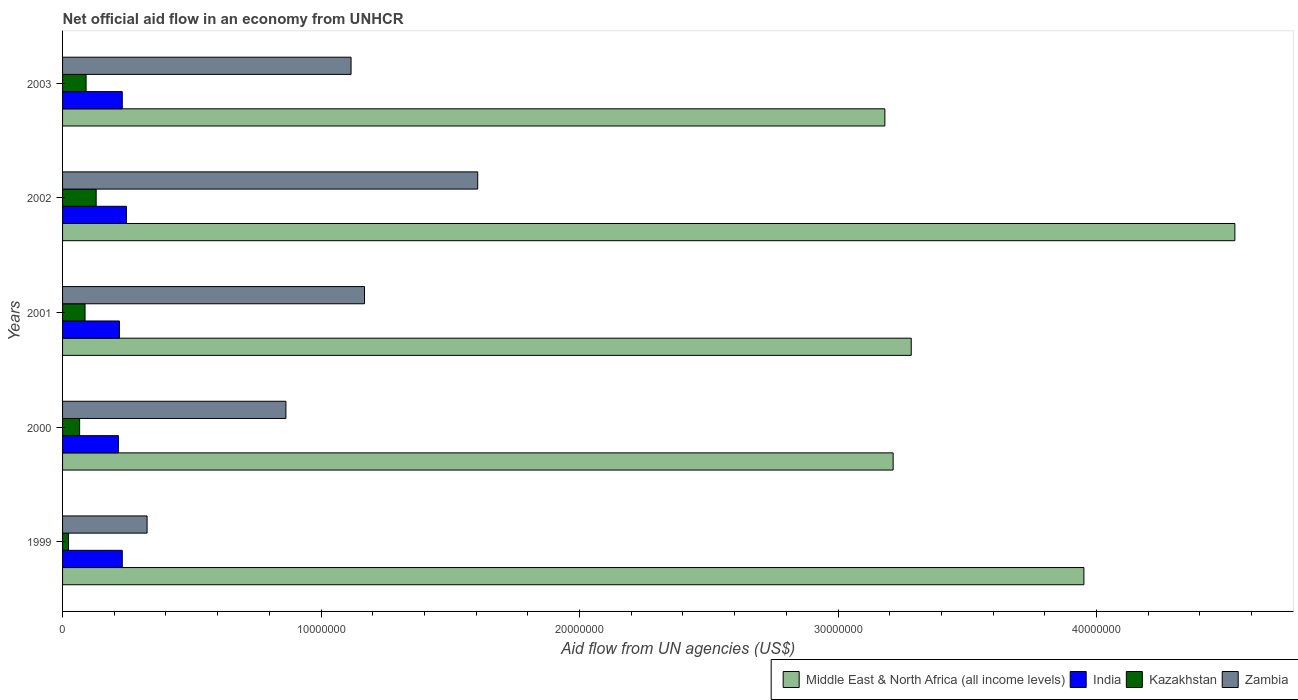How many different coloured bars are there?
Make the answer very short. 4. Are the number of bars on each tick of the Y-axis equal?
Your answer should be very brief. Yes. How many bars are there on the 2nd tick from the top?
Provide a succinct answer. 4. What is the label of the 4th group of bars from the top?
Give a very brief answer. 2000. What is the net official aid flow in Middle East & North Africa (all income levels) in 2001?
Your answer should be compact. 3.28e+07. Across all years, what is the maximum net official aid flow in Middle East & North Africa (all income levels)?
Keep it short and to the point. 4.54e+07. Across all years, what is the minimum net official aid flow in Middle East & North Africa (all income levels)?
Make the answer very short. 3.18e+07. In which year was the net official aid flow in Middle East & North Africa (all income levels) minimum?
Provide a short and direct response. 2003. What is the total net official aid flow in Middle East & North Africa (all income levels) in the graph?
Make the answer very short. 1.82e+08. What is the difference between the net official aid flow in Middle East & North Africa (all income levels) in 2000 and that in 2001?
Your response must be concise. -7.00e+05. What is the difference between the net official aid flow in Kazakhstan in 1999 and the net official aid flow in Middle East & North Africa (all income levels) in 2003?
Your response must be concise. -3.16e+07. What is the average net official aid flow in Zambia per year?
Keep it short and to the point. 1.02e+07. In the year 2001, what is the difference between the net official aid flow in India and net official aid flow in Middle East & North Africa (all income levels)?
Ensure brevity in your answer.  -3.06e+07. In how many years, is the net official aid flow in Middle East & North Africa (all income levels) greater than 20000000 US$?
Provide a short and direct response. 5. What is the ratio of the net official aid flow in Kazakhstan in 2000 to that in 2002?
Give a very brief answer. 0.51. Is the net official aid flow in Kazakhstan in 2001 less than that in 2003?
Offer a very short reply. Yes. Is the difference between the net official aid flow in India in 2001 and 2002 greater than the difference between the net official aid flow in Middle East & North Africa (all income levels) in 2001 and 2002?
Ensure brevity in your answer.  Yes. What is the difference between the highest and the lowest net official aid flow in India?
Your answer should be very brief. 3.10e+05. In how many years, is the net official aid flow in Zambia greater than the average net official aid flow in Zambia taken over all years?
Make the answer very short. 3. Is the sum of the net official aid flow in Zambia in 1999 and 2002 greater than the maximum net official aid flow in Middle East & North Africa (all income levels) across all years?
Offer a very short reply. No. What does the 3rd bar from the bottom in 2000 represents?
Keep it short and to the point. Kazakhstan. Is it the case that in every year, the sum of the net official aid flow in Middle East & North Africa (all income levels) and net official aid flow in Kazakhstan is greater than the net official aid flow in Zambia?
Keep it short and to the point. Yes. Does the graph contain grids?
Your answer should be compact. No. How many legend labels are there?
Ensure brevity in your answer.  4. How are the legend labels stacked?
Offer a very short reply. Horizontal. What is the title of the graph?
Your response must be concise. Net official aid flow in an economy from UNHCR. Does "Mozambique" appear as one of the legend labels in the graph?
Provide a short and direct response. No. What is the label or title of the X-axis?
Provide a short and direct response. Aid flow from UN agencies (US$). What is the Aid flow from UN agencies (US$) in Middle East & North Africa (all income levels) in 1999?
Offer a very short reply. 3.95e+07. What is the Aid flow from UN agencies (US$) of India in 1999?
Give a very brief answer. 2.31e+06. What is the Aid flow from UN agencies (US$) in Kazakhstan in 1999?
Offer a very short reply. 2.30e+05. What is the Aid flow from UN agencies (US$) in Zambia in 1999?
Ensure brevity in your answer.  3.27e+06. What is the Aid flow from UN agencies (US$) of Middle East & North Africa (all income levels) in 2000?
Offer a terse response. 3.21e+07. What is the Aid flow from UN agencies (US$) in India in 2000?
Make the answer very short. 2.16e+06. What is the Aid flow from UN agencies (US$) of Zambia in 2000?
Make the answer very short. 8.64e+06. What is the Aid flow from UN agencies (US$) of Middle East & North Africa (all income levels) in 2001?
Ensure brevity in your answer.  3.28e+07. What is the Aid flow from UN agencies (US$) of India in 2001?
Offer a terse response. 2.20e+06. What is the Aid flow from UN agencies (US$) of Kazakhstan in 2001?
Offer a terse response. 8.70e+05. What is the Aid flow from UN agencies (US$) in Zambia in 2001?
Give a very brief answer. 1.17e+07. What is the Aid flow from UN agencies (US$) in Middle East & North Africa (all income levels) in 2002?
Offer a very short reply. 4.54e+07. What is the Aid flow from UN agencies (US$) in India in 2002?
Provide a succinct answer. 2.47e+06. What is the Aid flow from UN agencies (US$) in Kazakhstan in 2002?
Provide a short and direct response. 1.30e+06. What is the Aid flow from UN agencies (US$) in Zambia in 2002?
Your answer should be very brief. 1.61e+07. What is the Aid flow from UN agencies (US$) in Middle East & North Africa (all income levels) in 2003?
Your response must be concise. 3.18e+07. What is the Aid flow from UN agencies (US$) of India in 2003?
Your answer should be very brief. 2.31e+06. What is the Aid flow from UN agencies (US$) of Kazakhstan in 2003?
Provide a succinct answer. 9.10e+05. What is the Aid flow from UN agencies (US$) in Zambia in 2003?
Offer a terse response. 1.12e+07. Across all years, what is the maximum Aid flow from UN agencies (US$) of Middle East & North Africa (all income levels)?
Your answer should be very brief. 4.54e+07. Across all years, what is the maximum Aid flow from UN agencies (US$) of India?
Ensure brevity in your answer.  2.47e+06. Across all years, what is the maximum Aid flow from UN agencies (US$) in Kazakhstan?
Your response must be concise. 1.30e+06. Across all years, what is the maximum Aid flow from UN agencies (US$) in Zambia?
Your answer should be very brief. 1.61e+07. Across all years, what is the minimum Aid flow from UN agencies (US$) in Middle East & North Africa (all income levels)?
Ensure brevity in your answer.  3.18e+07. Across all years, what is the minimum Aid flow from UN agencies (US$) in India?
Your response must be concise. 2.16e+06. Across all years, what is the minimum Aid flow from UN agencies (US$) of Zambia?
Your answer should be compact. 3.27e+06. What is the total Aid flow from UN agencies (US$) of Middle East & North Africa (all income levels) in the graph?
Your answer should be compact. 1.82e+08. What is the total Aid flow from UN agencies (US$) of India in the graph?
Offer a terse response. 1.14e+07. What is the total Aid flow from UN agencies (US$) in Kazakhstan in the graph?
Provide a short and direct response. 3.97e+06. What is the total Aid flow from UN agencies (US$) in Zambia in the graph?
Provide a succinct answer. 5.08e+07. What is the difference between the Aid flow from UN agencies (US$) of Middle East & North Africa (all income levels) in 1999 and that in 2000?
Keep it short and to the point. 7.38e+06. What is the difference between the Aid flow from UN agencies (US$) in India in 1999 and that in 2000?
Your response must be concise. 1.50e+05. What is the difference between the Aid flow from UN agencies (US$) of Kazakhstan in 1999 and that in 2000?
Provide a succinct answer. -4.30e+05. What is the difference between the Aid flow from UN agencies (US$) in Zambia in 1999 and that in 2000?
Provide a short and direct response. -5.37e+06. What is the difference between the Aid flow from UN agencies (US$) in Middle East & North Africa (all income levels) in 1999 and that in 2001?
Offer a very short reply. 6.68e+06. What is the difference between the Aid flow from UN agencies (US$) in India in 1999 and that in 2001?
Ensure brevity in your answer.  1.10e+05. What is the difference between the Aid flow from UN agencies (US$) of Kazakhstan in 1999 and that in 2001?
Give a very brief answer. -6.40e+05. What is the difference between the Aid flow from UN agencies (US$) in Zambia in 1999 and that in 2001?
Provide a succinct answer. -8.41e+06. What is the difference between the Aid flow from UN agencies (US$) in Middle East & North Africa (all income levels) in 1999 and that in 2002?
Make the answer very short. -5.84e+06. What is the difference between the Aid flow from UN agencies (US$) in India in 1999 and that in 2002?
Ensure brevity in your answer.  -1.60e+05. What is the difference between the Aid flow from UN agencies (US$) in Kazakhstan in 1999 and that in 2002?
Your response must be concise. -1.07e+06. What is the difference between the Aid flow from UN agencies (US$) of Zambia in 1999 and that in 2002?
Keep it short and to the point. -1.28e+07. What is the difference between the Aid flow from UN agencies (US$) in Middle East & North Africa (all income levels) in 1999 and that in 2003?
Keep it short and to the point. 7.70e+06. What is the difference between the Aid flow from UN agencies (US$) in Kazakhstan in 1999 and that in 2003?
Your response must be concise. -6.80e+05. What is the difference between the Aid flow from UN agencies (US$) of Zambia in 1999 and that in 2003?
Ensure brevity in your answer.  -7.89e+06. What is the difference between the Aid flow from UN agencies (US$) in Middle East & North Africa (all income levels) in 2000 and that in 2001?
Offer a very short reply. -7.00e+05. What is the difference between the Aid flow from UN agencies (US$) of Zambia in 2000 and that in 2001?
Keep it short and to the point. -3.04e+06. What is the difference between the Aid flow from UN agencies (US$) in Middle East & North Africa (all income levels) in 2000 and that in 2002?
Your response must be concise. -1.32e+07. What is the difference between the Aid flow from UN agencies (US$) of India in 2000 and that in 2002?
Offer a very short reply. -3.10e+05. What is the difference between the Aid flow from UN agencies (US$) of Kazakhstan in 2000 and that in 2002?
Give a very brief answer. -6.40e+05. What is the difference between the Aid flow from UN agencies (US$) in Zambia in 2000 and that in 2002?
Your answer should be compact. -7.42e+06. What is the difference between the Aid flow from UN agencies (US$) of Zambia in 2000 and that in 2003?
Ensure brevity in your answer.  -2.52e+06. What is the difference between the Aid flow from UN agencies (US$) of Middle East & North Africa (all income levels) in 2001 and that in 2002?
Offer a terse response. -1.25e+07. What is the difference between the Aid flow from UN agencies (US$) in Kazakhstan in 2001 and that in 2002?
Offer a very short reply. -4.30e+05. What is the difference between the Aid flow from UN agencies (US$) of Zambia in 2001 and that in 2002?
Provide a succinct answer. -4.38e+06. What is the difference between the Aid flow from UN agencies (US$) in Middle East & North Africa (all income levels) in 2001 and that in 2003?
Your answer should be compact. 1.02e+06. What is the difference between the Aid flow from UN agencies (US$) of Zambia in 2001 and that in 2003?
Offer a terse response. 5.20e+05. What is the difference between the Aid flow from UN agencies (US$) of Middle East & North Africa (all income levels) in 2002 and that in 2003?
Provide a succinct answer. 1.35e+07. What is the difference between the Aid flow from UN agencies (US$) in Kazakhstan in 2002 and that in 2003?
Your answer should be very brief. 3.90e+05. What is the difference between the Aid flow from UN agencies (US$) in Zambia in 2002 and that in 2003?
Your answer should be compact. 4.90e+06. What is the difference between the Aid flow from UN agencies (US$) of Middle East & North Africa (all income levels) in 1999 and the Aid flow from UN agencies (US$) of India in 2000?
Give a very brief answer. 3.74e+07. What is the difference between the Aid flow from UN agencies (US$) in Middle East & North Africa (all income levels) in 1999 and the Aid flow from UN agencies (US$) in Kazakhstan in 2000?
Ensure brevity in your answer.  3.88e+07. What is the difference between the Aid flow from UN agencies (US$) in Middle East & North Africa (all income levels) in 1999 and the Aid flow from UN agencies (US$) in Zambia in 2000?
Provide a short and direct response. 3.09e+07. What is the difference between the Aid flow from UN agencies (US$) of India in 1999 and the Aid flow from UN agencies (US$) of Kazakhstan in 2000?
Your response must be concise. 1.65e+06. What is the difference between the Aid flow from UN agencies (US$) in India in 1999 and the Aid flow from UN agencies (US$) in Zambia in 2000?
Ensure brevity in your answer.  -6.33e+06. What is the difference between the Aid flow from UN agencies (US$) of Kazakhstan in 1999 and the Aid flow from UN agencies (US$) of Zambia in 2000?
Keep it short and to the point. -8.41e+06. What is the difference between the Aid flow from UN agencies (US$) of Middle East & North Africa (all income levels) in 1999 and the Aid flow from UN agencies (US$) of India in 2001?
Your answer should be compact. 3.73e+07. What is the difference between the Aid flow from UN agencies (US$) of Middle East & North Africa (all income levels) in 1999 and the Aid flow from UN agencies (US$) of Kazakhstan in 2001?
Provide a succinct answer. 3.86e+07. What is the difference between the Aid flow from UN agencies (US$) of Middle East & North Africa (all income levels) in 1999 and the Aid flow from UN agencies (US$) of Zambia in 2001?
Your answer should be compact. 2.78e+07. What is the difference between the Aid flow from UN agencies (US$) of India in 1999 and the Aid flow from UN agencies (US$) of Kazakhstan in 2001?
Your answer should be very brief. 1.44e+06. What is the difference between the Aid flow from UN agencies (US$) of India in 1999 and the Aid flow from UN agencies (US$) of Zambia in 2001?
Ensure brevity in your answer.  -9.37e+06. What is the difference between the Aid flow from UN agencies (US$) in Kazakhstan in 1999 and the Aid flow from UN agencies (US$) in Zambia in 2001?
Offer a terse response. -1.14e+07. What is the difference between the Aid flow from UN agencies (US$) in Middle East & North Africa (all income levels) in 1999 and the Aid flow from UN agencies (US$) in India in 2002?
Your answer should be compact. 3.70e+07. What is the difference between the Aid flow from UN agencies (US$) in Middle East & North Africa (all income levels) in 1999 and the Aid flow from UN agencies (US$) in Kazakhstan in 2002?
Your answer should be compact. 3.82e+07. What is the difference between the Aid flow from UN agencies (US$) in Middle East & North Africa (all income levels) in 1999 and the Aid flow from UN agencies (US$) in Zambia in 2002?
Your answer should be very brief. 2.34e+07. What is the difference between the Aid flow from UN agencies (US$) of India in 1999 and the Aid flow from UN agencies (US$) of Kazakhstan in 2002?
Keep it short and to the point. 1.01e+06. What is the difference between the Aid flow from UN agencies (US$) of India in 1999 and the Aid flow from UN agencies (US$) of Zambia in 2002?
Ensure brevity in your answer.  -1.38e+07. What is the difference between the Aid flow from UN agencies (US$) of Kazakhstan in 1999 and the Aid flow from UN agencies (US$) of Zambia in 2002?
Make the answer very short. -1.58e+07. What is the difference between the Aid flow from UN agencies (US$) of Middle East & North Africa (all income levels) in 1999 and the Aid flow from UN agencies (US$) of India in 2003?
Offer a terse response. 3.72e+07. What is the difference between the Aid flow from UN agencies (US$) in Middle East & North Africa (all income levels) in 1999 and the Aid flow from UN agencies (US$) in Kazakhstan in 2003?
Offer a very short reply. 3.86e+07. What is the difference between the Aid flow from UN agencies (US$) in Middle East & North Africa (all income levels) in 1999 and the Aid flow from UN agencies (US$) in Zambia in 2003?
Your answer should be very brief. 2.84e+07. What is the difference between the Aid flow from UN agencies (US$) of India in 1999 and the Aid flow from UN agencies (US$) of Kazakhstan in 2003?
Your answer should be compact. 1.40e+06. What is the difference between the Aid flow from UN agencies (US$) in India in 1999 and the Aid flow from UN agencies (US$) in Zambia in 2003?
Provide a succinct answer. -8.85e+06. What is the difference between the Aid flow from UN agencies (US$) in Kazakhstan in 1999 and the Aid flow from UN agencies (US$) in Zambia in 2003?
Give a very brief answer. -1.09e+07. What is the difference between the Aid flow from UN agencies (US$) of Middle East & North Africa (all income levels) in 2000 and the Aid flow from UN agencies (US$) of India in 2001?
Your answer should be compact. 2.99e+07. What is the difference between the Aid flow from UN agencies (US$) in Middle East & North Africa (all income levels) in 2000 and the Aid flow from UN agencies (US$) in Kazakhstan in 2001?
Make the answer very short. 3.13e+07. What is the difference between the Aid flow from UN agencies (US$) in Middle East & North Africa (all income levels) in 2000 and the Aid flow from UN agencies (US$) in Zambia in 2001?
Provide a succinct answer. 2.04e+07. What is the difference between the Aid flow from UN agencies (US$) of India in 2000 and the Aid flow from UN agencies (US$) of Kazakhstan in 2001?
Ensure brevity in your answer.  1.29e+06. What is the difference between the Aid flow from UN agencies (US$) of India in 2000 and the Aid flow from UN agencies (US$) of Zambia in 2001?
Your response must be concise. -9.52e+06. What is the difference between the Aid flow from UN agencies (US$) in Kazakhstan in 2000 and the Aid flow from UN agencies (US$) in Zambia in 2001?
Provide a succinct answer. -1.10e+07. What is the difference between the Aid flow from UN agencies (US$) of Middle East & North Africa (all income levels) in 2000 and the Aid flow from UN agencies (US$) of India in 2002?
Provide a short and direct response. 2.97e+07. What is the difference between the Aid flow from UN agencies (US$) in Middle East & North Africa (all income levels) in 2000 and the Aid flow from UN agencies (US$) in Kazakhstan in 2002?
Your response must be concise. 3.08e+07. What is the difference between the Aid flow from UN agencies (US$) of Middle East & North Africa (all income levels) in 2000 and the Aid flow from UN agencies (US$) of Zambia in 2002?
Your answer should be very brief. 1.61e+07. What is the difference between the Aid flow from UN agencies (US$) in India in 2000 and the Aid flow from UN agencies (US$) in Kazakhstan in 2002?
Keep it short and to the point. 8.60e+05. What is the difference between the Aid flow from UN agencies (US$) of India in 2000 and the Aid flow from UN agencies (US$) of Zambia in 2002?
Your response must be concise. -1.39e+07. What is the difference between the Aid flow from UN agencies (US$) of Kazakhstan in 2000 and the Aid flow from UN agencies (US$) of Zambia in 2002?
Your answer should be compact. -1.54e+07. What is the difference between the Aid flow from UN agencies (US$) in Middle East & North Africa (all income levels) in 2000 and the Aid flow from UN agencies (US$) in India in 2003?
Provide a succinct answer. 2.98e+07. What is the difference between the Aid flow from UN agencies (US$) in Middle East & North Africa (all income levels) in 2000 and the Aid flow from UN agencies (US$) in Kazakhstan in 2003?
Your answer should be very brief. 3.12e+07. What is the difference between the Aid flow from UN agencies (US$) of Middle East & North Africa (all income levels) in 2000 and the Aid flow from UN agencies (US$) of Zambia in 2003?
Ensure brevity in your answer.  2.10e+07. What is the difference between the Aid flow from UN agencies (US$) in India in 2000 and the Aid flow from UN agencies (US$) in Kazakhstan in 2003?
Provide a succinct answer. 1.25e+06. What is the difference between the Aid flow from UN agencies (US$) in India in 2000 and the Aid flow from UN agencies (US$) in Zambia in 2003?
Provide a short and direct response. -9.00e+06. What is the difference between the Aid flow from UN agencies (US$) in Kazakhstan in 2000 and the Aid flow from UN agencies (US$) in Zambia in 2003?
Your answer should be compact. -1.05e+07. What is the difference between the Aid flow from UN agencies (US$) of Middle East & North Africa (all income levels) in 2001 and the Aid flow from UN agencies (US$) of India in 2002?
Your response must be concise. 3.04e+07. What is the difference between the Aid flow from UN agencies (US$) of Middle East & North Africa (all income levels) in 2001 and the Aid flow from UN agencies (US$) of Kazakhstan in 2002?
Make the answer very short. 3.15e+07. What is the difference between the Aid flow from UN agencies (US$) in Middle East & North Africa (all income levels) in 2001 and the Aid flow from UN agencies (US$) in Zambia in 2002?
Your answer should be compact. 1.68e+07. What is the difference between the Aid flow from UN agencies (US$) of India in 2001 and the Aid flow from UN agencies (US$) of Zambia in 2002?
Ensure brevity in your answer.  -1.39e+07. What is the difference between the Aid flow from UN agencies (US$) of Kazakhstan in 2001 and the Aid flow from UN agencies (US$) of Zambia in 2002?
Your response must be concise. -1.52e+07. What is the difference between the Aid flow from UN agencies (US$) of Middle East & North Africa (all income levels) in 2001 and the Aid flow from UN agencies (US$) of India in 2003?
Give a very brief answer. 3.05e+07. What is the difference between the Aid flow from UN agencies (US$) in Middle East & North Africa (all income levels) in 2001 and the Aid flow from UN agencies (US$) in Kazakhstan in 2003?
Offer a very short reply. 3.19e+07. What is the difference between the Aid flow from UN agencies (US$) in Middle East & North Africa (all income levels) in 2001 and the Aid flow from UN agencies (US$) in Zambia in 2003?
Give a very brief answer. 2.17e+07. What is the difference between the Aid flow from UN agencies (US$) in India in 2001 and the Aid flow from UN agencies (US$) in Kazakhstan in 2003?
Provide a short and direct response. 1.29e+06. What is the difference between the Aid flow from UN agencies (US$) in India in 2001 and the Aid flow from UN agencies (US$) in Zambia in 2003?
Ensure brevity in your answer.  -8.96e+06. What is the difference between the Aid flow from UN agencies (US$) in Kazakhstan in 2001 and the Aid flow from UN agencies (US$) in Zambia in 2003?
Your answer should be very brief. -1.03e+07. What is the difference between the Aid flow from UN agencies (US$) in Middle East & North Africa (all income levels) in 2002 and the Aid flow from UN agencies (US$) in India in 2003?
Your answer should be very brief. 4.30e+07. What is the difference between the Aid flow from UN agencies (US$) in Middle East & North Africa (all income levels) in 2002 and the Aid flow from UN agencies (US$) in Kazakhstan in 2003?
Make the answer very short. 4.44e+07. What is the difference between the Aid flow from UN agencies (US$) in Middle East & North Africa (all income levels) in 2002 and the Aid flow from UN agencies (US$) in Zambia in 2003?
Your answer should be very brief. 3.42e+07. What is the difference between the Aid flow from UN agencies (US$) in India in 2002 and the Aid flow from UN agencies (US$) in Kazakhstan in 2003?
Ensure brevity in your answer.  1.56e+06. What is the difference between the Aid flow from UN agencies (US$) of India in 2002 and the Aid flow from UN agencies (US$) of Zambia in 2003?
Provide a short and direct response. -8.69e+06. What is the difference between the Aid flow from UN agencies (US$) of Kazakhstan in 2002 and the Aid flow from UN agencies (US$) of Zambia in 2003?
Offer a very short reply. -9.86e+06. What is the average Aid flow from UN agencies (US$) of Middle East & North Africa (all income levels) per year?
Provide a succinct answer. 3.63e+07. What is the average Aid flow from UN agencies (US$) in India per year?
Offer a very short reply. 2.29e+06. What is the average Aid flow from UN agencies (US$) of Kazakhstan per year?
Offer a terse response. 7.94e+05. What is the average Aid flow from UN agencies (US$) in Zambia per year?
Ensure brevity in your answer.  1.02e+07. In the year 1999, what is the difference between the Aid flow from UN agencies (US$) in Middle East & North Africa (all income levels) and Aid flow from UN agencies (US$) in India?
Provide a succinct answer. 3.72e+07. In the year 1999, what is the difference between the Aid flow from UN agencies (US$) in Middle East & North Africa (all income levels) and Aid flow from UN agencies (US$) in Kazakhstan?
Your answer should be compact. 3.93e+07. In the year 1999, what is the difference between the Aid flow from UN agencies (US$) of Middle East & North Africa (all income levels) and Aid flow from UN agencies (US$) of Zambia?
Make the answer very short. 3.62e+07. In the year 1999, what is the difference between the Aid flow from UN agencies (US$) of India and Aid flow from UN agencies (US$) of Kazakhstan?
Provide a short and direct response. 2.08e+06. In the year 1999, what is the difference between the Aid flow from UN agencies (US$) in India and Aid flow from UN agencies (US$) in Zambia?
Make the answer very short. -9.60e+05. In the year 1999, what is the difference between the Aid flow from UN agencies (US$) of Kazakhstan and Aid flow from UN agencies (US$) of Zambia?
Offer a very short reply. -3.04e+06. In the year 2000, what is the difference between the Aid flow from UN agencies (US$) in Middle East & North Africa (all income levels) and Aid flow from UN agencies (US$) in India?
Offer a terse response. 3.00e+07. In the year 2000, what is the difference between the Aid flow from UN agencies (US$) in Middle East & North Africa (all income levels) and Aid flow from UN agencies (US$) in Kazakhstan?
Make the answer very short. 3.15e+07. In the year 2000, what is the difference between the Aid flow from UN agencies (US$) of Middle East & North Africa (all income levels) and Aid flow from UN agencies (US$) of Zambia?
Your response must be concise. 2.35e+07. In the year 2000, what is the difference between the Aid flow from UN agencies (US$) in India and Aid flow from UN agencies (US$) in Kazakhstan?
Offer a very short reply. 1.50e+06. In the year 2000, what is the difference between the Aid flow from UN agencies (US$) of India and Aid flow from UN agencies (US$) of Zambia?
Offer a very short reply. -6.48e+06. In the year 2000, what is the difference between the Aid flow from UN agencies (US$) in Kazakhstan and Aid flow from UN agencies (US$) in Zambia?
Your answer should be compact. -7.98e+06. In the year 2001, what is the difference between the Aid flow from UN agencies (US$) of Middle East & North Africa (all income levels) and Aid flow from UN agencies (US$) of India?
Make the answer very short. 3.06e+07. In the year 2001, what is the difference between the Aid flow from UN agencies (US$) of Middle East & North Africa (all income levels) and Aid flow from UN agencies (US$) of Kazakhstan?
Ensure brevity in your answer.  3.20e+07. In the year 2001, what is the difference between the Aid flow from UN agencies (US$) of Middle East & North Africa (all income levels) and Aid flow from UN agencies (US$) of Zambia?
Ensure brevity in your answer.  2.12e+07. In the year 2001, what is the difference between the Aid flow from UN agencies (US$) of India and Aid flow from UN agencies (US$) of Kazakhstan?
Provide a succinct answer. 1.33e+06. In the year 2001, what is the difference between the Aid flow from UN agencies (US$) in India and Aid flow from UN agencies (US$) in Zambia?
Give a very brief answer. -9.48e+06. In the year 2001, what is the difference between the Aid flow from UN agencies (US$) of Kazakhstan and Aid flow from UN agencies (US$) of Zambia?
Give a very brief answer. -1.08e+07. In the year 2002, what is the difference between the Aid flow from UN agencies (US$) in Middle East & North Africa (all income levels) and Aid flow from UN agencies (US$) in India?
Your answer should be compact. 4.29e+07. In the year 2002, what is the difference between the Aid flow from UN agencies (US$) in Middle East & North Africa (all income levels) and Aid flow from UN agencies (US$) in Kazakhstan?
Offer a terse response. 4.40e+07. In the year 2002, what is the difference between the Aid flow from UN agencies (US$) in Middle East & North Africa (all income levels) and Aid flow from UN agencies (US$) in Zambia?
Your answer should be compact. 2.93e+07. In the year 2002, what is the difference between the Aid flow from UN agencies (US$) in India and Aid flow from UN agencies (US$) in Kazakhstan?
Your answer should be very brief. 1.17e+06. In the year 2002, what is the difference between the Aid flow from UN agencies (US$) in India and Aid flow from UN agencies (US$) in Zambia?
Provide a short and direct response. -1.36e+07. In the year 2002, what is the difference between the Aid flow from UN agencies (US$) of Kazakhstan and Aid flow from UN agencies (US$) of Zambia?
Give a very brief answer. -1.48e+07. In the year 2003, what is the difference between the Aid flow from UN agencies (US$) in Middle East & North Africa (all income levels) and Aid flow from UN agencies (US$) in India?
Your answer should be compact. 2.95e+07. In the year 2003, what is the difference between the Aid flow from UN agencies (US$) in Middle East & North Africa (all income levels) and Aid flow from UN agencies (US$) in Kazakhstan?
Provide a short and direct response. 3.09e+07. In the year 2003, what is the difference between the Aid flow from UN agencies (US$) of Middle East & North Africa (all income levels) and Aid flow from UN agencies (US$) of Zambia?
Your response must be concise. 2.06e+07. In the year 2003, what is the difference between the Aid flow from UN agencies (US$) in India and Aid flow from UN agencies (US$) in Kazakhstan?
Make the answer very short. 1.40e+06. In the year 2003, what is the difference between the Aid flow from UN agencies (US$) of India and Aid flow from UN agencies (US$) of Zambia?
Offer a terse response. -8.85e+06. In the year 2003, what is the difference between the Aid flow from UN agencies (US$) in Kazakhstan and Aid flow from UN agencies (US$) in Zambia?
Give a very brief answer. -1.02e+07. What is the ratio of the Aid flow from UN agencies (US$) in Middle East & North Africa (all income levels) in 1999 to that in 2000?
Give a very brief answer. 1.23. What is the ratio of the Aid flow from UN agencies (US$) of India in 1999 to that in 2000?
Give a very brief answer. 1.07. What is the ratio of the Aid flow from UN agencies (US$) in Kazakhstan in 1999 to that in 2000?
Keep it short and to the point. 0.35. What is the ratio of the Aid flow from UN agencies (US$) in Zambia in 1999 to that in 2000?
Your response must be concise. 0.38. What is the ratio of the Aid flow from UN agencies (US$) of Middle East & North Africa (all income levels) in 1999 to that in 2001?
Your response must be concise. 1.2. What is the ratio of the Aid flow from UN agencies (US$) of India in 1999 to that in 2001?
Offer a very short reply. 1.05. What is the ratio of the Aid flow from UN agencies (US$) of Kazakhstan in 1999 to that in 2001?
Offer a very short reply. 0.26. What is the ratio of the Aid flow from UN agencies (US$) of Zambia in 1999 to that in 2001?
Offer a very short reply. 0.28. What is the ratio of the Aid flow from UN agencies (US$) of Middle East & North Africa (all income levels) in 1999 to that in 2002?
Keep it short and to the point. 0.87. What is the ratio of the Aid flow from UN agencies (US$) of India in 1999 to that in 2002?
Keep it short and to the point. 0.94. What is the ratio of the Aid flow from UN agencies (US$) in Kazakhstan in 1999 to that in 2002?
Your answer should be compact. 0.18. What is the ratio of the Aid flow from UN agencies (US$) in Zambia in 1999 to that in 2002?
Provide a short and direct response. 0.2. What is the ratio of the Aid flow from UN agencies (US$) in Middle East & North Africa (all income levels) in 1999 to that in 2003?
Your answer should be very brief. 1.24. What is the ratio of the Aid flow from UN agencies (US$) in Kazakhstan in 1999 to that in 2003?
Keep it short and to the point. 0.25. What is the ratio of the Aid flow from UN agencies (US$) of Zambia in 1999 to that in 2003?
Offer a very short reply. 0.29. What is the ratio of the Aid flow from UN agencies (US$) of Middle East & North Africa (all income levels) in 2000 to that in 2001?
Give a very brief answer. 0.98. What is the ratio of the Aid flow from UN agencies (US$) of India in 2000 to that in 2001?
Provide a short and direct response. 0.98. What is the ratio of the Aid flow from UN agencies (US$) in Kazakhstan in 2000 to that in 2001?
Provide a short and direct response. 0.76. What is the ratio of the Aid flow from UN agencies (US$) in Zambia in 2000 to that in 2001?
Offer a very short reply. 0.74. What is the ratio of the Aid flow from UN agencies (US$) in Middle East & North Africa (all income levels) in 2000 to that in 2002?
Offer a very short reply. 0.71. What is the ratio of the Aid flow from UN agencies (US$) in India in 2000 to that in 2002?
Give a very brief answer. 0.87. What is the ratio of the Aid flow from UN agencies (US$) of Kazakhstan in 2000 to that in 2002?
Your answer should be compact. 0.51. What is the ratio of the Aid flow from UN agencies (US$) of Zambia in 2000 to that in 2002?
Provide a succinct answer. 0.54. What is the ratio of the Aid flow from UN agencies (US$) of Middle East & North Africa (all income levels) in 2000 to that in 2003?
Offer a very short reply. 1.01. What is the ratio of the Aid flow from UN agencies (US$) in India in 2000 to that in 2003?
Make the answer very short. 0.94. What is the ratio of the Aid flow from UN agencies (US$) of Kazakhstan in 2000 to that in 2003?
Your answer should be very brief. 0.73. What is the ratio of the Aid flow from UN agencies (US$) of Zambia in 2000 to that in 2003?
Provide a succinct answer. 0.77. What is the ratio of the Aid flow from UN agencies (US$) of Middle East & North Africa (all income levels) in 2001 to that in 2002?
Offer a terse response. 0.72. What is the ratio of the Aid flow from UN agencies (US$) in India in 2001 to that in 2002?
Give a very brief answer. 0.89. What is the ratio of the Aid flow from UN agencies (US$) in Kazakhstan in 2001 to that in 2002?
Make the answer very short. 0.67. What is the ratio of the Aid flow from UN agencies (US$) in Zambia in 2001 to that in 2002?
Provide a short and direct response. 0.73. What is the ratio of the Aid flow from UN agencies (US$) of Middle East & North Africa (all income levels) in 2001 to that in 2003?
Make the answer very short. 1.03. What is the ratio of the Aid flow from UN agencies (US$) in Kazakhstan in 2001 to that in 2003?
Offer a terse response. 0.96. What is the ratio of the Aid flow from UN agencies (US$) in Zambia in 2001 to that in 2003?
Ensure brevity in your answer.  1.05. What is the ratio of the Aid flow from UN agencies (US$) of Middle East & North Africa (all income levels) in 2002 to that in 2003?
Provide a succinct answer. 1.43. What is the ratio of the Aid flow from UN agencies (US$) in India in 2002 to that in 2003?
Give a very brief answer. 1.07. What is the ratio of the Aid flow from UN agencies (US$) of Kazakhstan in 2002 to that in 2003?
Make the answer very short. 1.43. What is the ratio of the Aid flow from UN agencies (US$) in Zambia in 2002 to that in 2003?
Your response must be concise. 1.44. What is the difference between the highest and the second highest Aid flow from UN agencies (US$) of Middle East & North Africa (all income levels)?
Offer a very short reply. 5.84e+06. What is the difference between the highest and the second highest Aid flow from UN agencies (US$) of India?
Ensure brevity in your answer.  1.60e+05. What is the difference between the highest and the second highest Aid flow from UN agencies (US$) of Kazakhstan?
Your answer should be compact. 3.90e+05. What is the difference between the highest and the second highest Aid flow from UN agencies (US$) of Zambia?
Provide a succinct answer. 4.38e+06. What is the difference between the highest and the lowest Aid flow from UN agencies (US$) of Middle East & North Africa (all income levels)?
Your answer should be compact. 1.35e+07. What is the difference between the highest and the lowest Aid flow from UN agencies (US$) in India?
Provide a short and direct response. 3.10e+05. What is the difference between the highest and the lowest Aid flow from UN agencies (US$) in Kazakhstan?
Provide a succinct answer. 1.07e+06. What is the difference between the highest and the lowest Aid flow from UN agencies (US$) of Zambia?
Your answer should be very brief. 1.28e+07. 